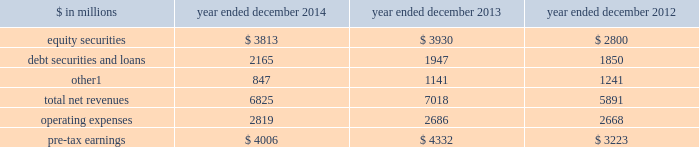Management 2019s discussion and analysis investing & lending investing & lending includes our investing activities and the origination of loans to provide financing to clients .
These investments and loans are typically longer-term in nature .
We make investments , some of which are consolidated , directly and indirectly through funds that we manage , in debt securities and loans , public and private equity securities , and real estate entities .
The table below presents the operating results of our investing & lending segment. .
Includes net revenues of $ 325 million for 2014 , $ 329 million for 2013 and $ 362 million for 2012 related to metro international trade services llc .
We completed the sale of this consolidated investment in december 2014 .
2014 versus 2013 .
Net revenues in investing & lending were $ 6.83 billion for 2014 , 3% ( 3 % ) lower than 2013 .
Net gains from investments in equity securities were slightly lower due to a significant decrease in net gains from investments in public equities , as movements in global equity prices during 2014 were less favorable compared with 2013 , partially offset by an increase in net gains from investments in private equities , primarily driven by company-specific events .
Net revenues from debt securities and loans were higher than 2013 , reflecting a significant increase in net interest income , primarily driven by increased lending , and a slight increase in net gains , primarily due to sales of certain investments during 2014 .
Other net revenues , related to our consolidated investments , were significantly lower compared with 2013 , reflecting a decrease in operating revenues from commodities-related consolidated investments .
During 2014 , net revenues in investing & lending generally reflected favorable company-specific events , including initial public offerings and financings , and strong corporate performance , as well as net gains from sales of certain investments .
However , concerns about the outlook for the global economy and uncertainty over the impact of financial regulatory reform continue to be meaningful considerations for the global marketplace .
If equity markets decline or credit spreads widen , net revenues in investing & lending would likely be negatively impacted .
Operating expenses were $ 2.82 billion for 2014 , 5% ( 5 % ) higher than 2013 , reflecting higher compensation and benefits expenses , partially offset by lower expenses related to consolidated investments .
Pre-tax earnings were $ 4.01 billion in 2014 , 8% ( 8 % ) lower than 2013 .
2013 versus 2012 .
Net revenues in investing & lending were $ 7.02 billion for 2013 , 19% ( 19 % ) higher than 2012 , reflecting a significant increase in net gains from investments in equity securities , driven by company-specific events and stronger corporate performance , as well as significantly higher global equity prices .
In addition , net gains and net interest income from debt securities and loans were slightly higher , while other net revenues , related to our consolidated investments , were lower compared with 2012 .
During 2013 , net revenues in investing & lending generally reflected favorable company-specific events and strong corporate performance , as well as the impact of significantly higher global equity prices and tighter corporate credit spreads .
Operating expenses were $ 2.69 billion for 2013 , essentially unchanged compared with 2012 .
Operating expenses during 2013 included lower impairment charges and lower operating expenses related to consolidated investments , partially offset by increased compensation and benefits expenses due to higher net revenues compared with 2012 .
Pre-tax earnings were $ 4.33 billion in 2013 , 34% ( 34 % ) higher than 2012 .
Goldman sachs 2014 annual report 45 .
In millions for 2014 2013 and 2012 , what was average equity securities? 
Computations: table_average(equity securities, none)
Answer: 3514.33333. 